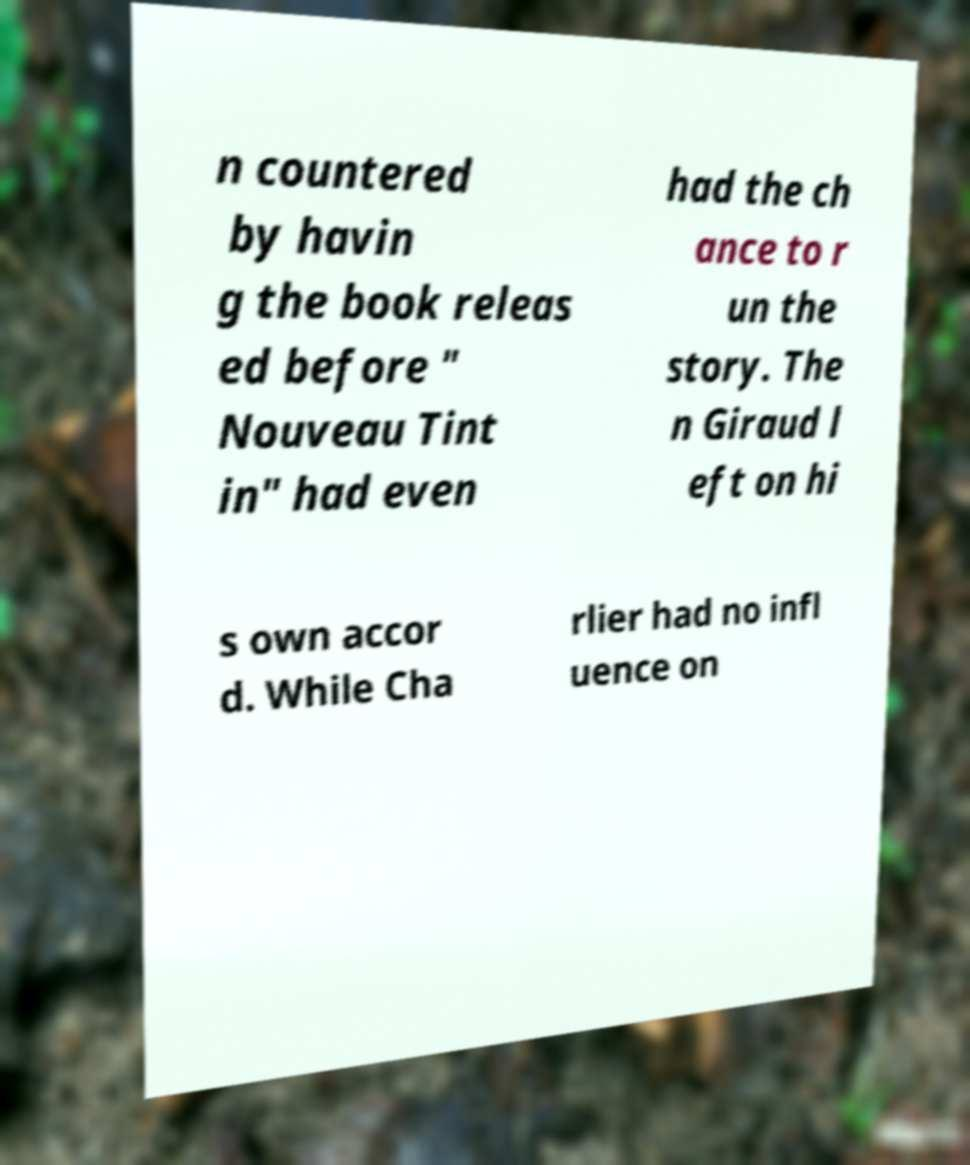Please identify and transcribe the text found in this image. n countered by havin g the book releas ed before " Nouveau Tint in" had even had the ch ance to r un the story. The n Giraud l eft on hi s own accor d. While Cha rlier had no infl uence on 